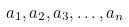<formula> <loc_0><loc_0><loc_500><loc_500>a _ { 1 } , a _ { 2 } , a _ { 3 } , \dots , a _ { n }</formula> 